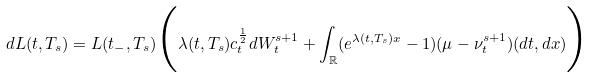Convert formula to latex. <formula><loc_0><loc_0><loc_500><loc_500>d L ( t , T _ { s } ) = L ( t _ { - } , T _ { s } ) \Big { ( } \lambda ( t , T _ { s } ) c _ { t } ^ { \frac { 1 } { 2 } } d W _ { t } ^ { s + 1 } + \int _ { \mathbb { R } } ( e ^ { \lambda ( t , T _ { s } ) x } - 1 ) ( \mu - \nu _ { t } ^ { s + 1 } ) ( d t , d x ) \Big { ) }</formula> 